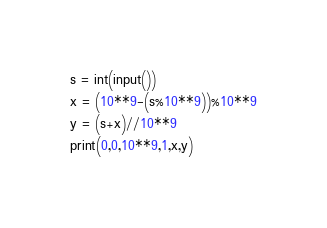<code> <loc_0><loc_0><loc_500><loc_500><_Python_>s = int(input())
x = (10**9-(s%10**9))%10**9
y = (s+x)//10**9
print(0,0,10**9,1,x,y)</code> 